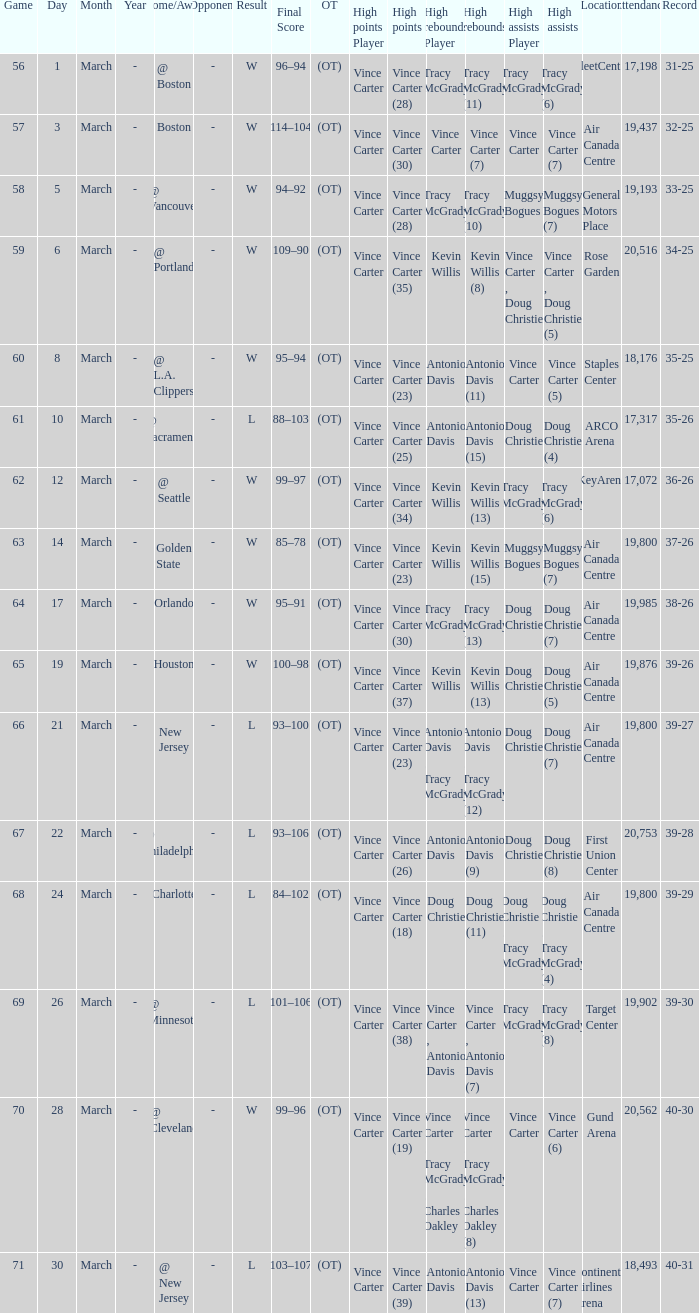Who was the high rebounder against charlotte? Doug Christie (11). 